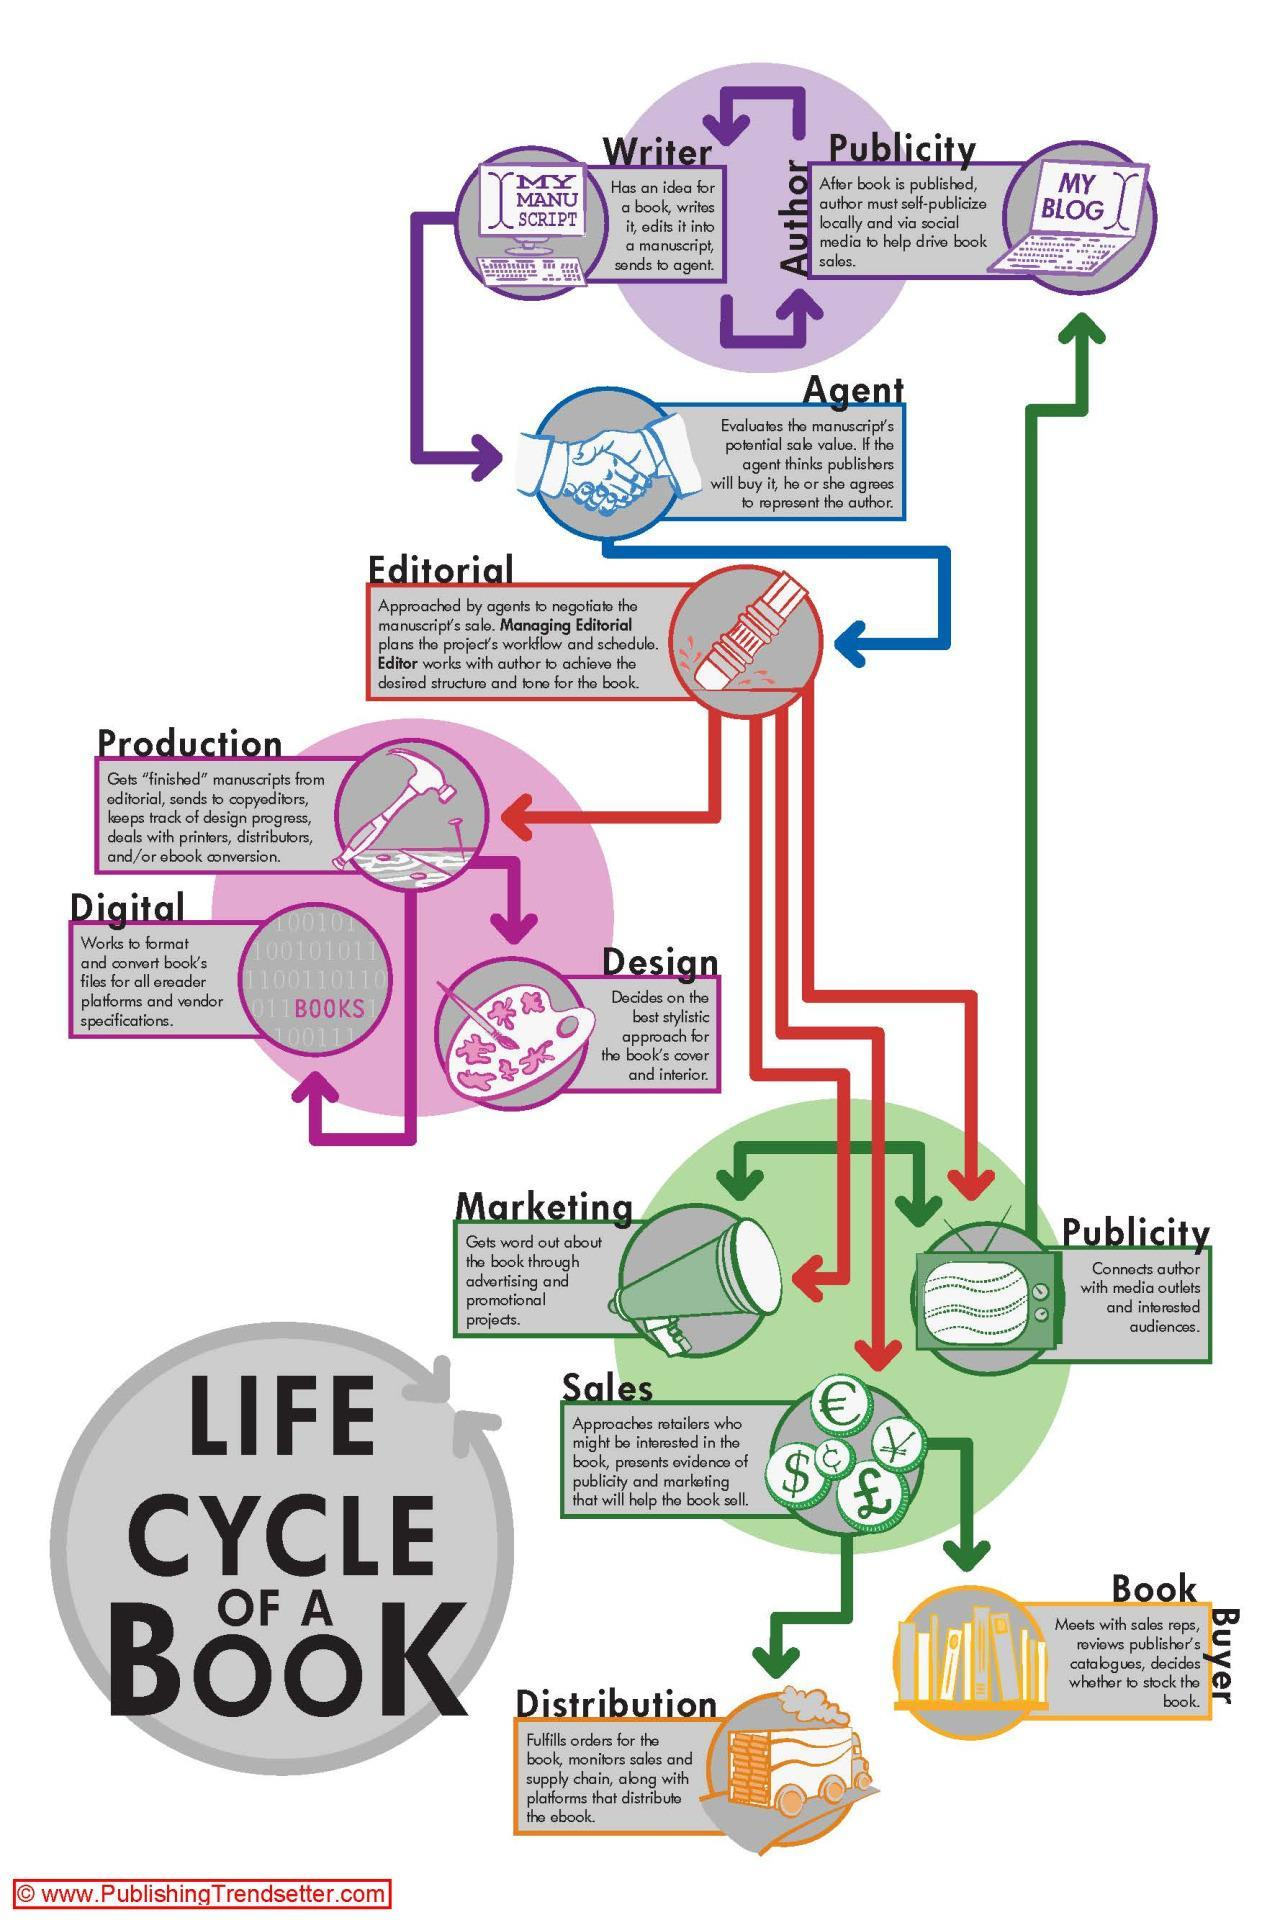who is the connecting link between writer and editorial?
Answer the question with a short phrase. agent which department connects editorial and distribution? sales 